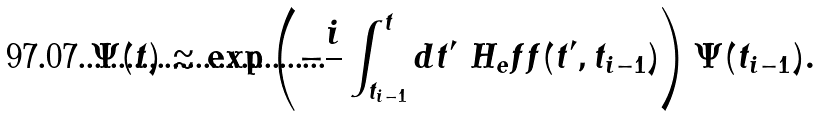<formula> <loc_0><loc_0><loc_500><loc_500>\Psi ( t ) \approx \exp \left ( - \frac { i } { } \int _ { t _ { i - 1 } } ^ { t } d t ^ { \prime } \ H _ { e } f f ( t ^ { \prime } , t _ { i - 1 } ) \right ) \Psi ( t _ { i - 1 } ) .</formula> 